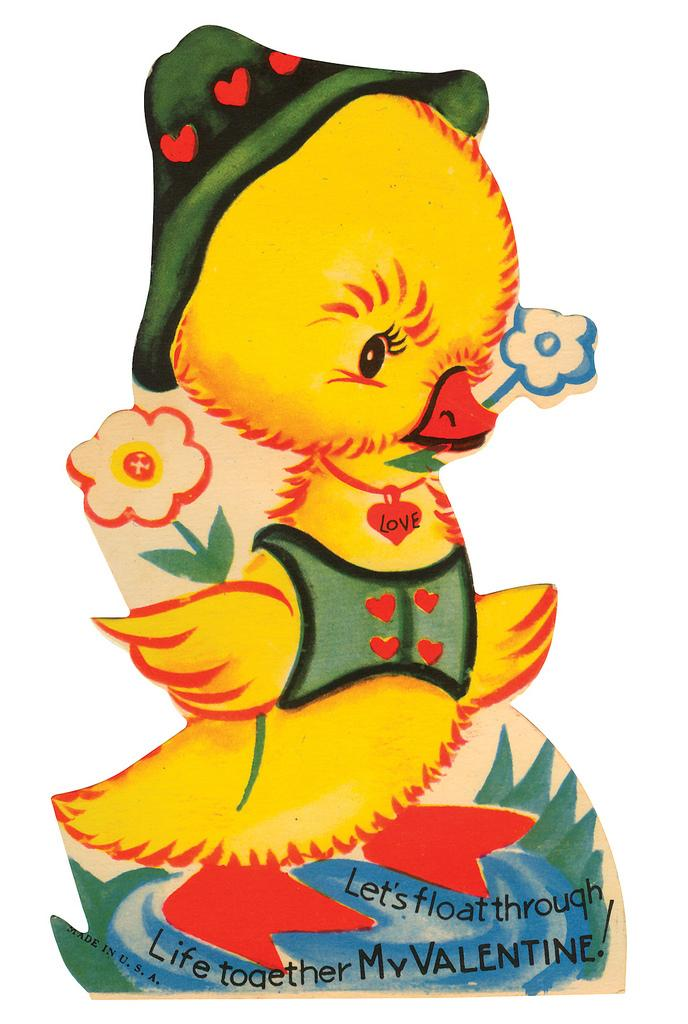What is the main subject of the image? There is a painting in the image. What type of muscle can be seen flexing in the painting? There is no muscle or any living beings present in the painting, as it is a still image. 